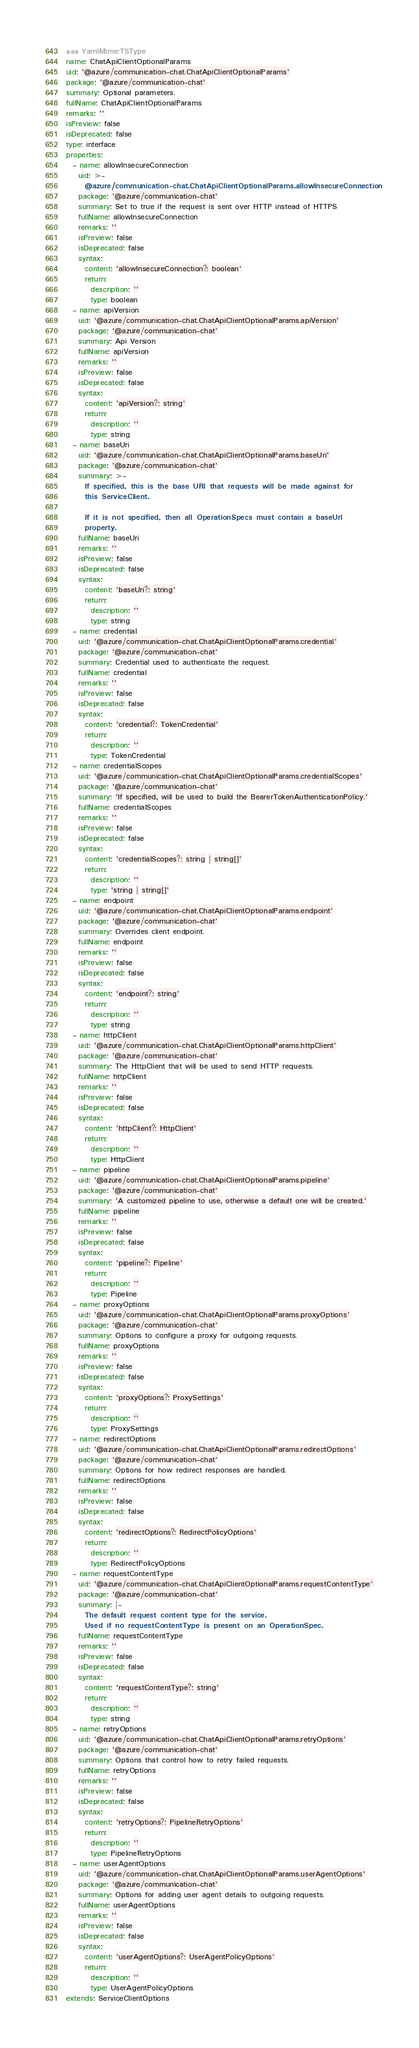Convert code to text. <code><loc_0><loc_0><loc_500><loc_500><_YAML_>### YamlMime:TSType
name: ChatApiClientOptionalParams
uid: '@azure/communication-chat.ChatApiClientOptionalParams'
package: '@azure/communication-chat'
summary: Optional parameters.
fullName: ChatApiClientOptionalParams
remarks: ''
isPreview: false
isDeprecated: false
type: interface
properties:
  - name: allowInsecureConnection
    uid: >-
      @azure/communication-chat.ChatApiClientOptionalParams.allowInsecureConnection
    package: '@azure/communication-chat'
    summary: Set to true if the request is sent over HTTP instead of HTTPS
    fullName: allowInsecureConnection
    remarks: ''
    isPreview: false
    isDeprecated: false
    syntax:
      content: 'allowInsecureConnection?: boolean'
      return:
        description: ''
        type: boolean
  - name: apiVersion
    uid: '@azure/communication-chat.ChatApiClientOptionalParams.apiVersion'
    package: '@azure/communication-chat'
    summary: Api Version
    fullName: apiVersion
    remarks: ''
    isPreview: false
    isDeprecated: false
    syntax:
      content: 'apiVersion?: string'
      return:
        description: ''
        type: string
  - name: baseUri
    uid: '@azure/communication-chat.ChatApiClientOptionalParams.baseUri'
    package: '@azure/communication-chat'
    summary: >-
      If specified, this is the base URI that requests will be made against for
      this ServiceClient.

      If it is not specified, then all OperationSpecs must contain a baseUrl
      property.
    fullName: baseUri
    remarks: ''
    isPreview: false
    isDeprecated: false
    syntax:
      content: 'baseUri?: string'
      return:
        description: ''
        type: string
  - name: credential
    uid: '@azure/communication-chat.ChatApiClientOptionalParams.credential'
    package: '@azure/communication-chat'
    summary: Credential used to authenticate the request.
    fullName: credential
    remarks: ''
    isPreview: false
    isDeprecated: false
    syntax:
      content: 'credential?: TokenCredential'
      return:
        description: ''
        type: TokenCredential
  - name: credentialScopes
    uid: '@azure/communication-chat.ChatApiClientOptionalParams.credentialScopes'
    package: '@azure/communication-chat'
    summary: 'If specified, will be used to build the BearerTokenAuthenticationPolicy.'
    fullName: credentialScopes
    remarks: ''
    isPreview: false
    isDeprecated: false
    syntax:
      content: 'credentialScopes?: string | string[]'
      return:
        description: ''
        type: 'string | string[]'
  - name: endpoint
    uid: '@azure/communication-chat.ChatApiClientOptionalParams.endpoint'
    package: '@azure/communication-chat'
    summary: Overrides client endpoint.
    fullName: endpoint
    remarks: ''
    isPreview: false
    isDeprecated: false
    syntax:
      content: 'endpoint?: string'
      return:
        description: ''
        type: string
  - name: httpClient
    uid: '@azure/communication-chat.ChatApiClientOptionalParams.httpClient'
    package: '@azure/communication-chat'
    summary: The HttpClient that will be used to send HTTP requests.
    fullName: httpClient
    remarks: ''
    isPreview: false
    isDeprecated: false
    syntax:
      content: 'httpClient?: HttpClient'
      return:
        description: ''
        type: HttpClient
  - name: pipeline
    uid: '@azure/communication-chat.ChatApiClientOptionalParams.pipeline'
    package: '@azure/communication-chat'
    summary: 'A customized pipeline to use, otherwise a default one will be created.'
    fullName: pipeline
    remarks: ''
    isPreview: false
    isDeprecated: false
    syntax:
      content: 'pipeline?: Pipeline'
      return:
        description: ''
        type: Pipeline
  - name: proxyOptions
    uid: '@azure/communication-chat.ChatApiClientOptionalParams.proxyOptions'
    package: '@azure/communication-chat'
    summary: Options to configure a proxy for outgoing requests.
    fullName: proxyOptions
    remarks: ''
    isPreview: false
    isDeprecated: false
    syntax:
      content: 'proxyOptions?: ProxySettings'
      return:
        description: ''
        type: ProxySettings
  - name: redirectOptions
    uid: '@azure/communication-chat.ChatApiClientOptionalParams.redirectOptions'
    package: '@azure/communication-chat'
    summary: Options for how redirect responses are handled.
    fullName: redirectOptions
    remarks: ''
    isPreview: false
    isDeprecated: false
    syntax:
      content: 'redirectOptions?: RedirectPolicyOptions'
      return:
        description: ''
        type: RedirectPolicyOptions
  - name: requestContentType
    uid: '@azure/communication-chat.ChatApiClientOptionalParams.requestContentType'
    package: '@azure/communication-chat'
    summary: |-
      The default request content type for the service.
      Used if no requestContentType is present on an OperationSpec.
    fullName: requestContentType
    remarks: ''
    isPreview: false
    isDeprecated: false
    syntax:
      content: 'requestContentType?: string'
      return:
        description: ''
        type: string
  - name: retryOptions
    uid: '@azure/communication-chat.ChatApiClientOptionalParams.retryOptions'
    package: '@azure/communication-chat'
    summary: Options that control how to retry failed requests.
    fullName: retryOptions
    remarks: ''
    isPreview: false
    isDeprecated: false
    syntax:
      content: 'retryOptions?: PipelineRetryOptions'
      return:
        description: ''
        type: PipelineRetryOptions
  - name: userAgentOptions
    uid: '@azure/communication-chat.ChatApiClientOptionalParams.userAgentOptions'
    package: '@azure/communication-chat'
    summary: Options for adding user agent details to outgoing requests.
    fullName: userAgentOptions
    remarks: ''
    isPreview: false
    isDeprecated: false
    syntax:
      content: 'userAgentOptions?: UserAgentPolicyOptions'
      return:
        description: ''
        type: UserAgentPolicyOptions
extends: ServiceClientOptions
</code> 